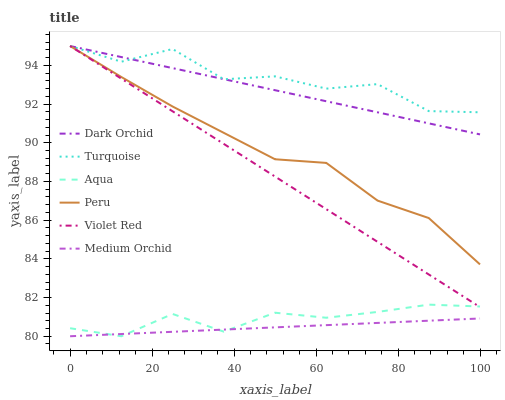Does Medium Orchid have the minimum area under the curve?
Answer yes or no. Yes. Does Turquoise have the maximum area under the curve?
Answer yes or no. Yes. Does Aqua have the minimum area under the curve?
Answer yes or no. No. Does Aqua have the maximum area under the curve?
Answer yes or no. No. Is Dark Orchid the smoothest?
Answer yes or no. Yes. Is Turquoise the roughest?
Answer yes or no. Yes. Is Medium Orchid the smoothest?
Answer yes or no. No. Is Medium Orchid the roughest?
Answer yes or no. No. Does Medium Orchid have the lowest value?
Answer yes or no. Yes. Does Turquoise have the lowest value?
Answer yes or no. No. Does Peru have the highest value?
Answer yes or no. Yes. Does Aqua have the highest value?
Answer yes or no. No. Is Medium Orchid less than Turquoise?
Answer yes or no. Yes. Is Violet Red greater than Medium Orchid?
Answer yes or no. Yes. Does Aqua intersect Medium Orchid?
Answer yes or no. Yes. Is Aqua less than Medium Orchid?
Answer yes or no. No. Is Aqua greater than Medium Orchid?
Answer yes or no. No. Does Medium Orchid intersect Turquoise?
Answer yes or no. No. 